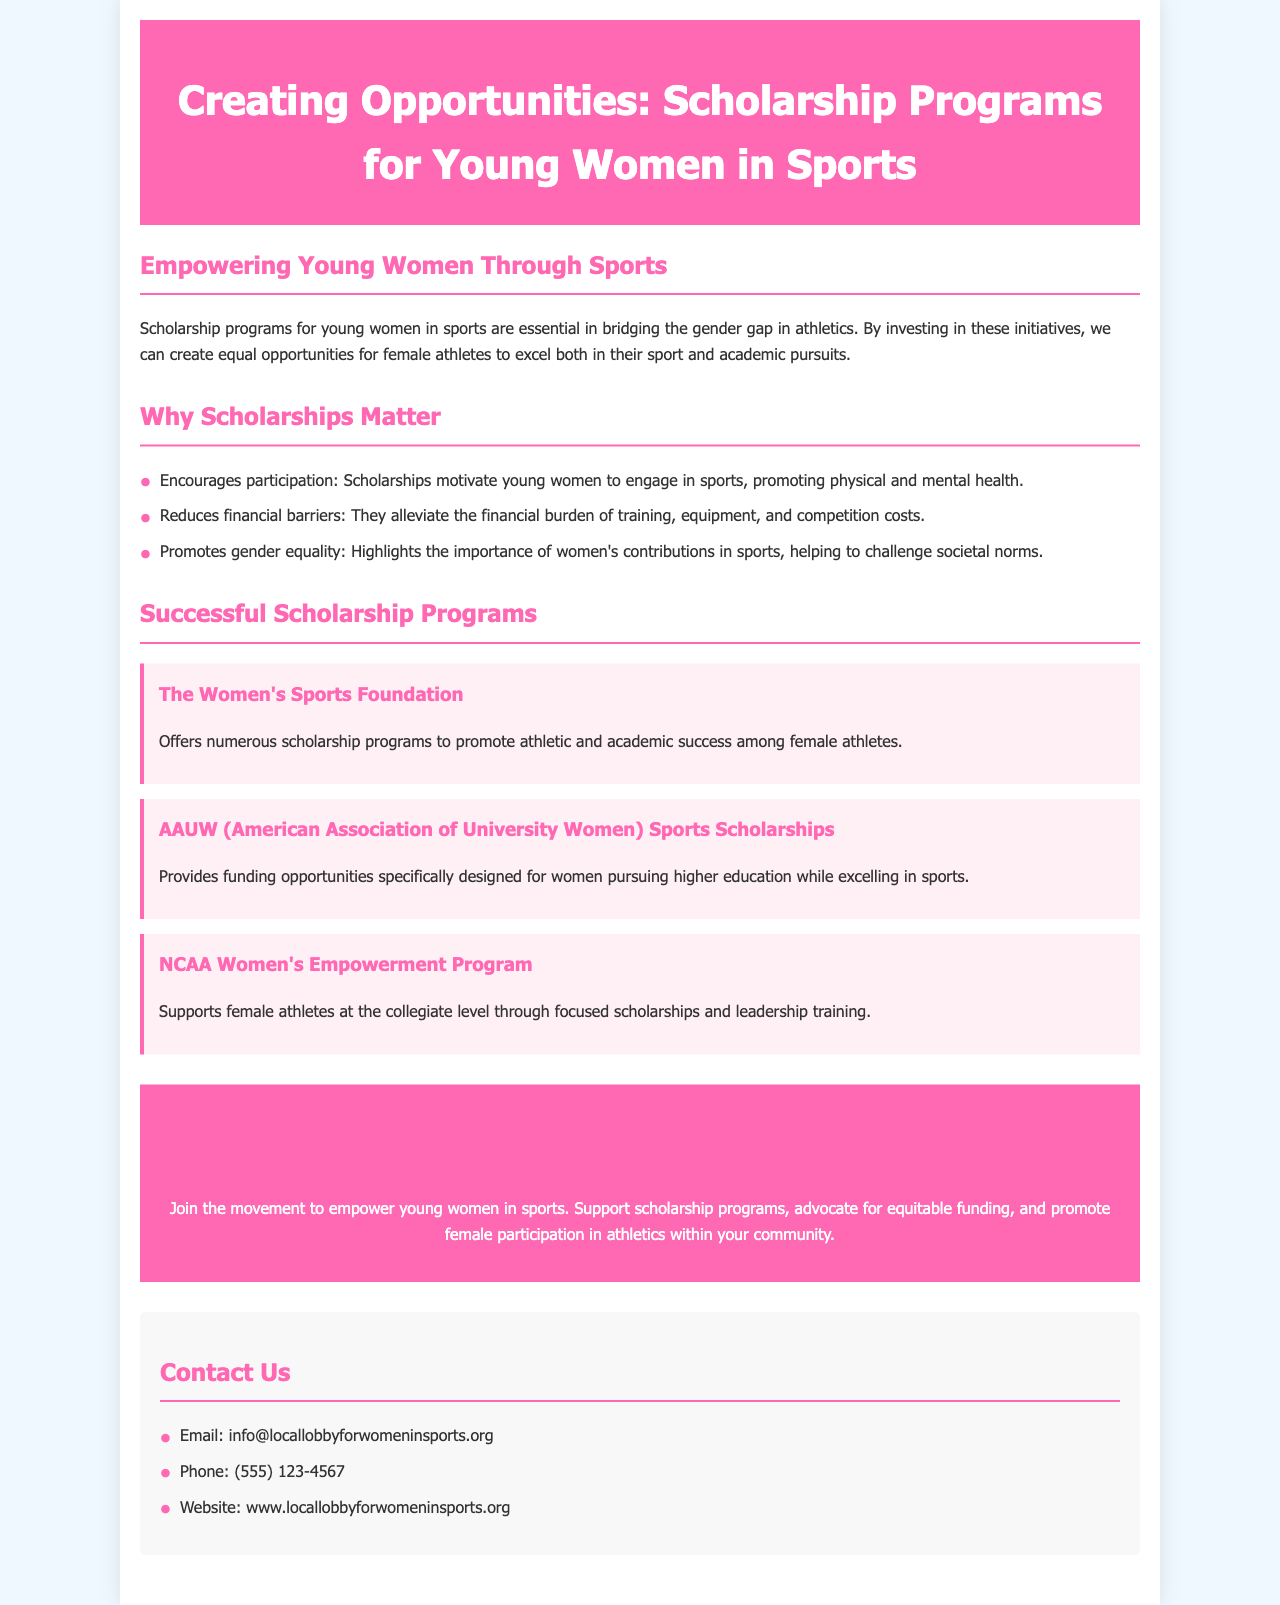What is the title of the brochure? The title of the brochure is presented prominently at the top of the document.
Answer: Creating Opportunities: Scholarship Programs for Young Women in Sports What organization offers athletic and academic scholarships to female athletes? The document mentions specific organizations that provide scholarships, identified by their names.
Answer: The Women's Sports Foundation What type of barriers do scholarships help to reduce? The document lists specific issues that scholarships address in the context of sports for young women.
Answer: Financial barriers How many successful scholarship programs are mentioned? The document enumerate the programs offered, allowing the reader to count them.
Answer: Three What is one benefit of scholarships for young women in sports? The brochure highlights several advantages of scholarship programs, emphasizing their impact.
Answer: Encourages participation Which program supports female athletes at the collegiate level? Specific programs are named in the document, indicating their focus and target audience.
Answer: NCAA Women's Empowerment Program What call to action is highlighted in the brochure? The document includes a section urging involvement and action towards a cause.
Answer: Get Involved What is the contact email provided in the brochure? Contact information is explicitly stated in the document, including email correspondence.
Answer: info@locallobbyforwomeninsports.org What color is the header of the brochure? The design elements of the brochure are described, including the main color used.
Answer: Pink 